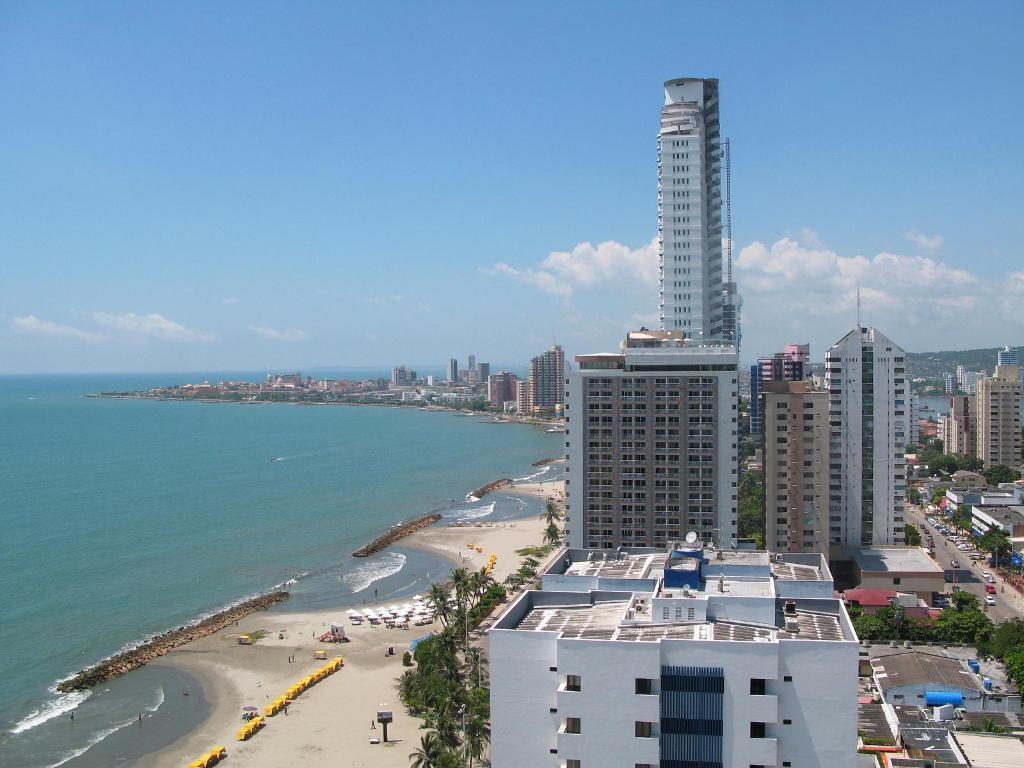What type of structures can be seen in the image? There are buildings in the image. What other natural elements are present in the image? There are trees in the image. What mode of transportation can be seen in the image? There are vehicles on the road in the image. What is visible on the left side of the image? There is water visible on the left side of the image. What else can be seen around the water on the left side of the image? There are unspecified things around the water on the left side of the image. What is the income of the trees in the image? Trees do not have income, as they are living organisms and not capable of earning money. How does the water on the left side of the image cover the buildings? The water on the left side of the image does not cover the buildings; they are separate elements in the image. 